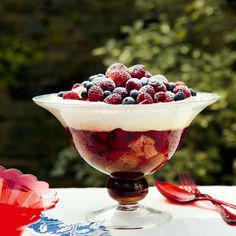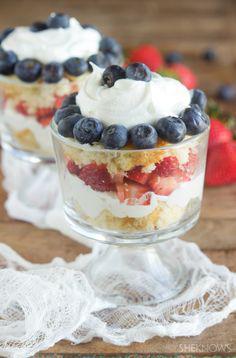The first image is the image on the left, the second image is the image on the right. Examine the images to the left and right. Is the description "An image shows side-by-side desserts with blueberries around the rim." accurate? Answer yes or no. Yes. The first image is the image on the left, the second image is the image on the right. Examine the images to the left and right. Is the description "In one image, two individual desserts have layers of strawberries and blueberries, and are topped with whipped cream." accurate? Answer yes or no. Yes. 